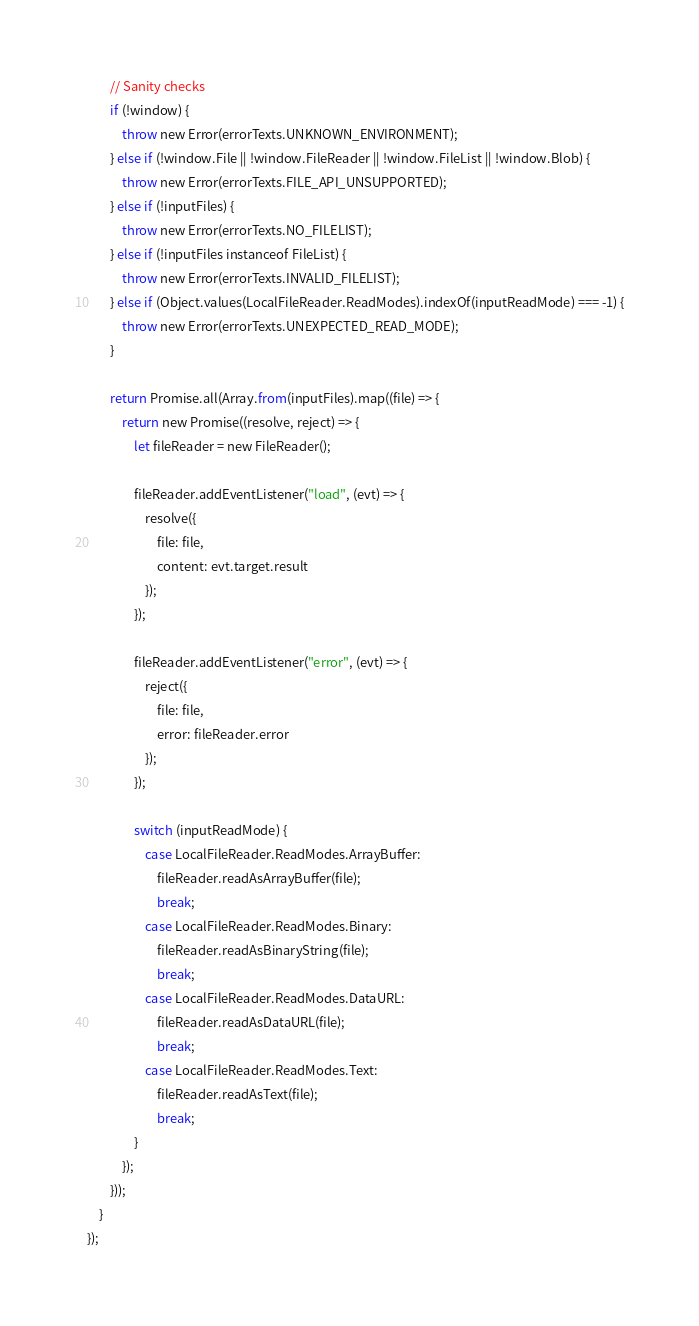<code> <loc_0><loc_0><loc_500><loc_500><_JavaScript_>
        // Sanity checks
        if (!window) {
            throw new Error(errorTexts.UNKNOWN_ENVIRONMENT);
        } else if (!window.File || !window.FileReader || !window.FileList || !window.Blob) {
            throw new Error(errorTexts.FILE_API_UNSUPPORTED);
        } else if (!inputFiles) {
            throw new Error(errorTexts.NO_FILELIST);
        } else if (!inputFiles instanceof FileList) {
            throw new Error(errorTexts.INVALID_FILELIST);
        } else if (Object.values(LocalFileReader.ReadModes).indexOf(inputReadMode) === -1) {
            throw new Error(errorTexts.UNEXPECTED_READ_MODE);
        }

        return Promise.all(Array.from(inputFiles).map((file) => {
            return new Promise((resolve, reject) => {
                let fileReader = new FileReader();

                fileReader.addEventListener("load", (evt) => {
                    resolve({
                        file: file,
                        content: evt.target.result
                    });
                });

                fileReader.addEventListener("error", (evt) => {
                    reject({
                        file: file,
                        error: fileReader.error
                    });
                });

                switch (inputReadMode) {
                    case LocalFileReader.ReadModes.ArrayBuffer:
                        fileReader.readAsArrayBuffer(file);
                        break;
                    case LocalFileReader.ReadModes.Binary:
                        fileReader.readAsBinaryString(file);
                        break;
                    case LocalFileReader.ReadModes.DataURL:
                        fileReader.readAsDataURL(file);
                        break;
                    case LocalFileReader.ReadModes.Text:
                        fileReader.readAsText(file);
                        break;
                }
            });
        }));
    }
});</code> 